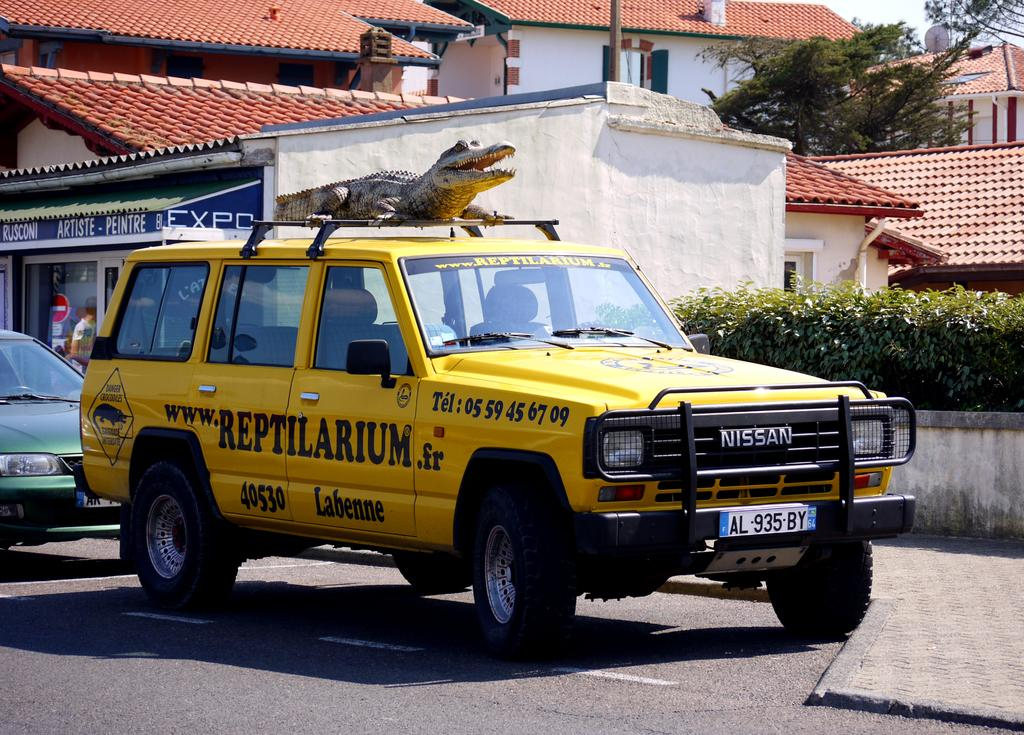<image>
Present a compact description of the photo's key features. A yellow SUV with "Reptilarium" written on the side doors. 